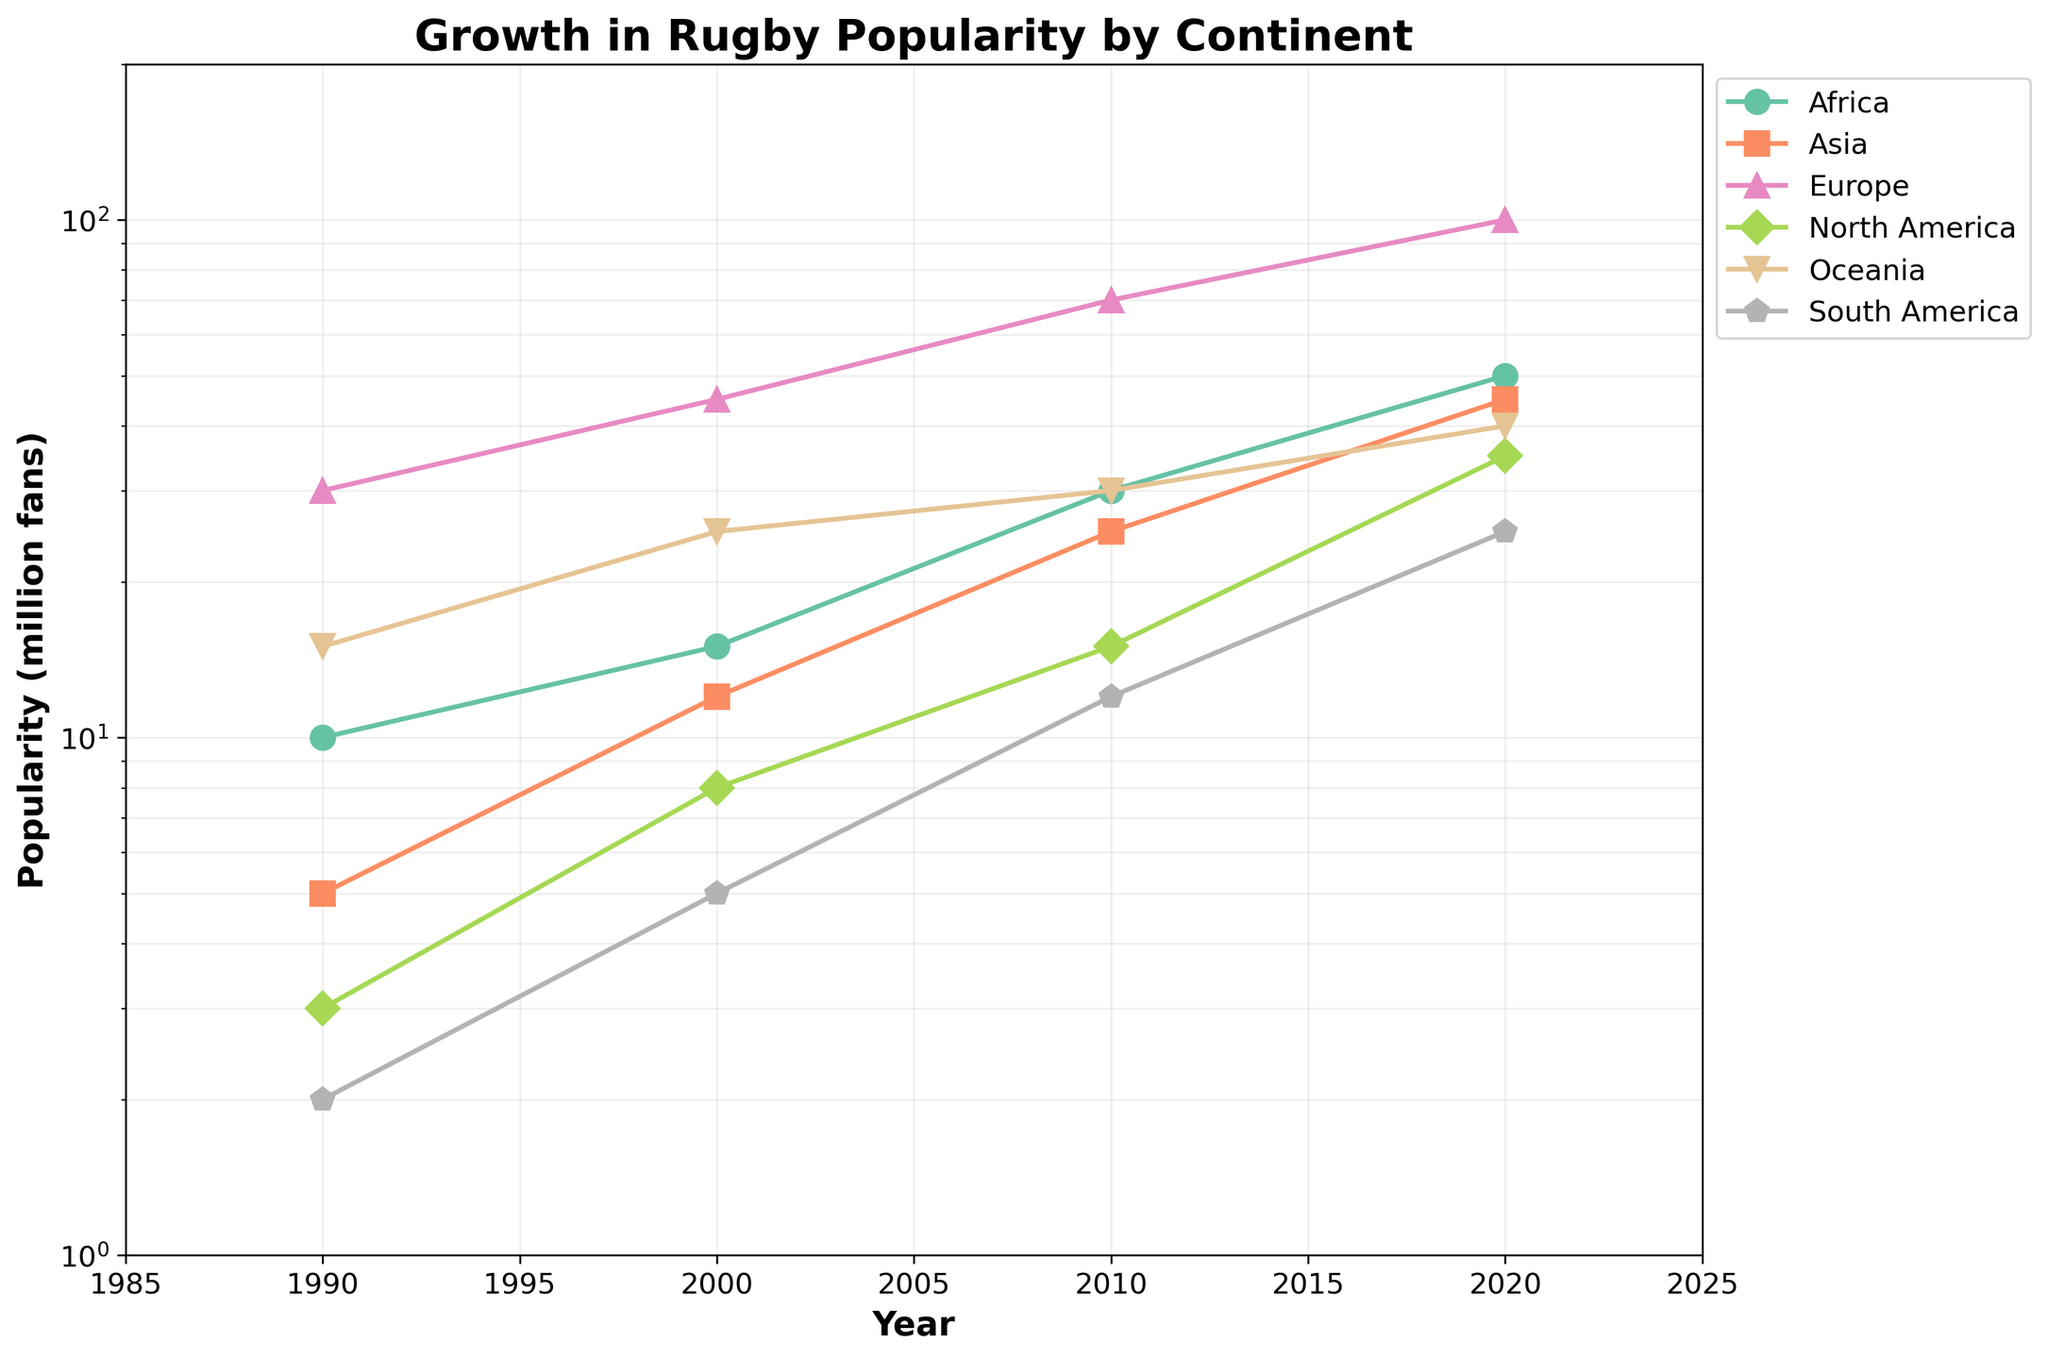What's the title of the plot? The title is usually located at the top of the plot and provides a brief description of what the plot represents.
Answer: Growth in Rugby Popularity by Continent Which continent had the highest popularity in 2020? By observing the plotted lines and their markers for the year 2020, we can identify the one positioned highest on the y-axis.
Answer: Europe What is the y-axis scale of the plot? Looking at the axis labels and noting that the values multiply by powers of 10, we can determine that the y-axis is on a logarithmic scale.
Answer: Logarithmic How did the popularity of rugby in Africa change from 1990 to 2020? By tracking the line for Africa from 1990 to 2020, we can observe the numerical change in popularity.
Answer: It increased from 10 million to 50 million Which continent showed the least growth in popularity from 1990 to 2020? By comparing the slopes of the lines, the flattest line indicates the smallest growth.
Answer: Oceania In which year did the popularity of rugby in North America first exceed that in South America? Find the point where the North America line crosses above the South America line for the first time.
Answer: 2000 Compare the growth in popularity between Asia and Europe between 2000 and 2010. Which continent experienced a higher percentage increase? Calculate the percentage increase for both continents by comparing their popularity values from 2000 to 2010.
Answer: Asia experienced a higher percentage increase Which continent experienced more than a threefold increase in popularity from 1990 to 2020? Identify continents where the popularity in 2020 is more than three times that in 1990.
Answer: Asia What is the approximate popularity of rugby in Oceania in 2010 as indicated in the plot? Locate the data point for Oceania in the year 2010 on the plot.
Answer: 30 million fans Between which years did Europe witness the sharpest increase in popularity? Identify the steepest part of the line representing Europe, indicating the years between which the popularity rose most rapidly.
Answer: 2000 to 2010 